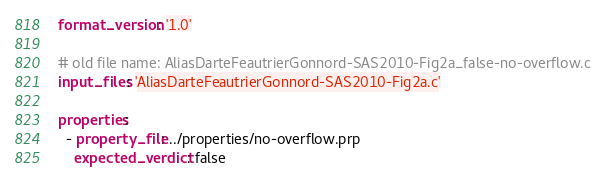Convert code to text. <code><loc_0><loc_0><loc_500><loc_500><_YAML_>format_version: '1.0'

# old file name: AliasDarteFeautrierGonnord-SAS2010-Fig2a_false-no-overflow.c
input_files: 'AliasDarteFeautrierGonnord-SAS2010-Fig2a.c'

properties:
  - property_file: ../properties/no-overflow.prp
    expected_verdict: false
</code> 